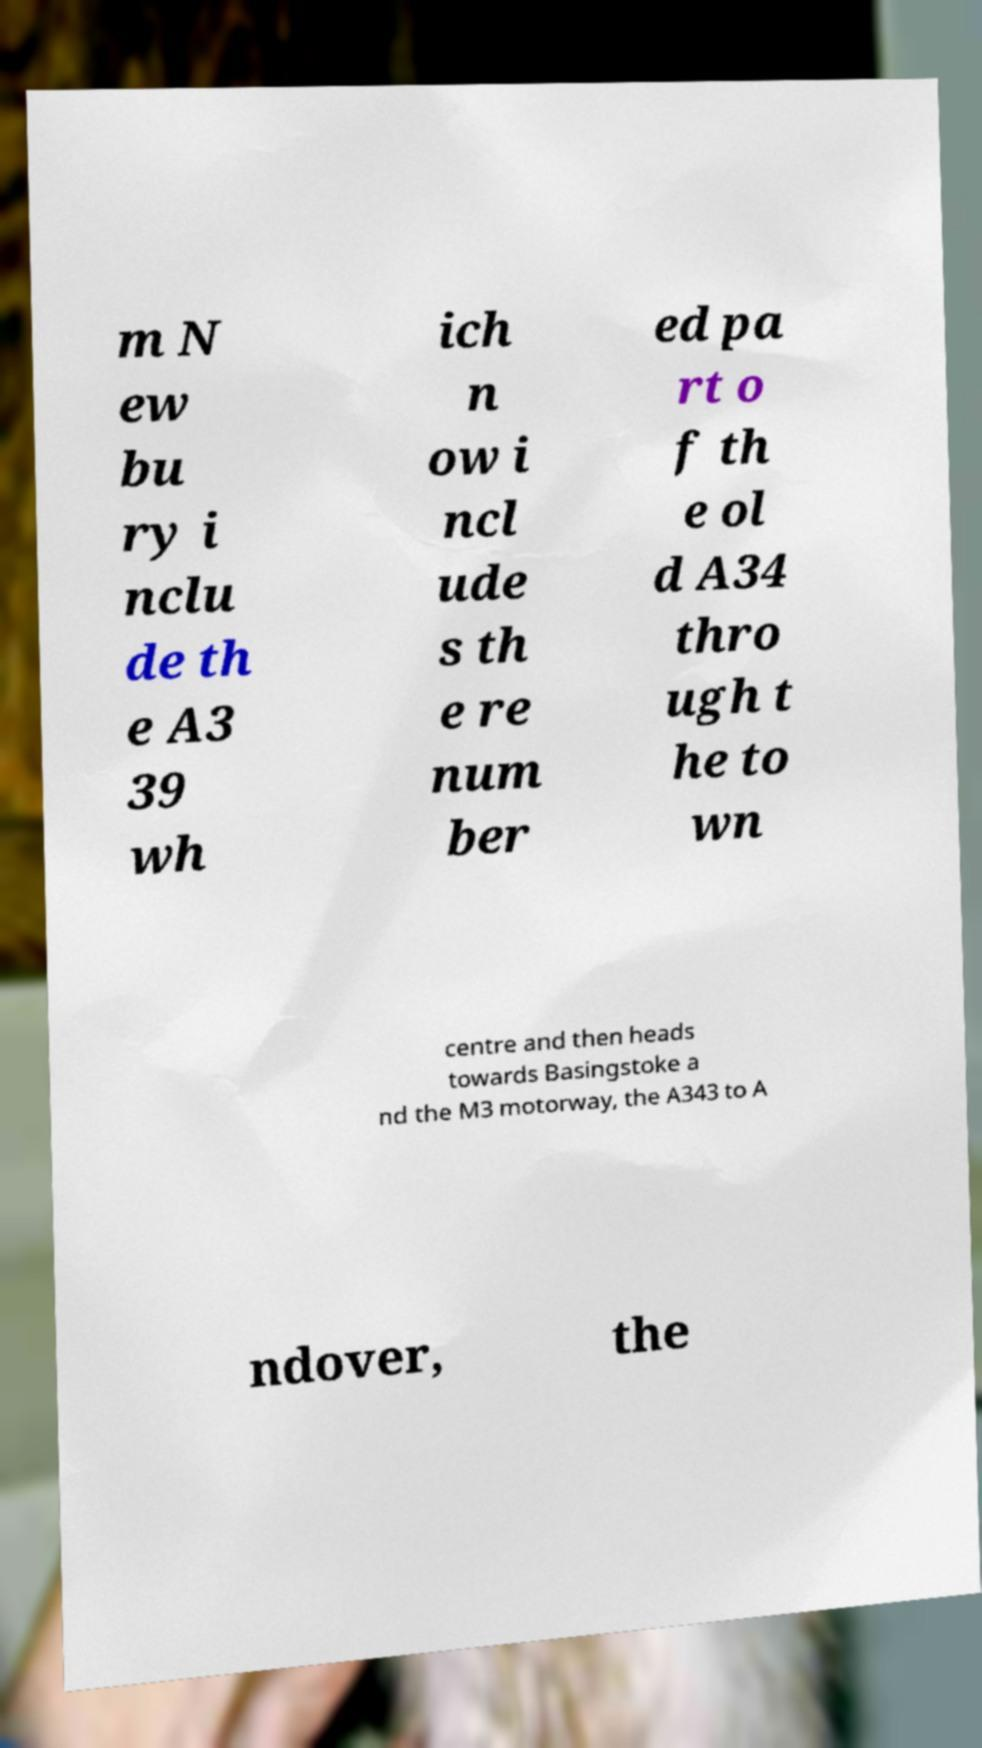What messages or text are displayed in this image? I need them in a readable, typed format. m N ew bu ry i nclu de th e A3 39 wh ich n ow i ncl ude s th e re num ber ed pa rt o f th e ol d A34 thro ugh t he to wn centre and then heads towards Basingstoke a nd the M3 motorway, the A343 to A ndover, the 